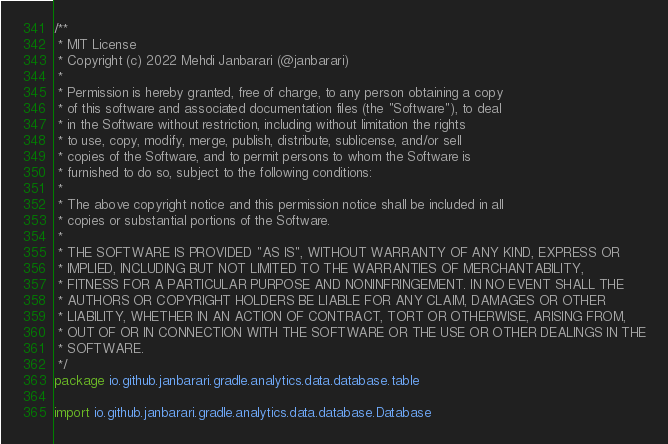Convert code to text. <code><loc_0><loc_0><loc_500><loc_500><_Kotlin_>/**
 * MIT License
 * Copyright (c) 2022 Mehdi Janbarari (@janbarari)
 *
 * Permission is hereby granted, free of charge, to any person obtaining a copy
 * of this software and associated documentation files (the "Software"), to deal
 * in the Software without restriction, including without limitation the rights
 * to use, copy, modify, merge, publish, distribute, sublicense, and/or sell
 * copies of the Software, and to permit persons to whom the Software is
 * furnished to do so, subject to the following conditions:
 *
 * The above copyright notice and this permission notice shall be included in all
 * copies or substantial portions of the Software.
 *
 * THE SOFTWARE IS PROVIDED "AS IS", WITHOUT WARRANTY OF ANY KIND, EXPRESS OR
 * IMPLIED, INCLUDING BUT NOT LIMITED TO THE WARRANTIES OF MERCHANTABILITY,
 * FITNESS FOR A PARTICULAR PURPOSE AND NONINFRINGEMENT. IN NO EVENT SHALL THE
 * AUTHORS OR COPYRIGHT HOLDERS BE LIABLE FOR ANY CLAIM, DAMAGES OR OTHER
 * LIABILITY, WHETHER IN AN ACTION OF CONTRACT, TORT OR OTHERWISE, ARISING FROM,
 * OUT OF OR IN CONNECTION WITH THE SOFTWARE OR THE USE OR OTHER DEALINGS IN THE
 * SOFTWARE.
 */
package io.github.janbarari.gradle.analytics.data.database.table

import io.github.janbarari.gradle.analytics.data.database.Database</code> 